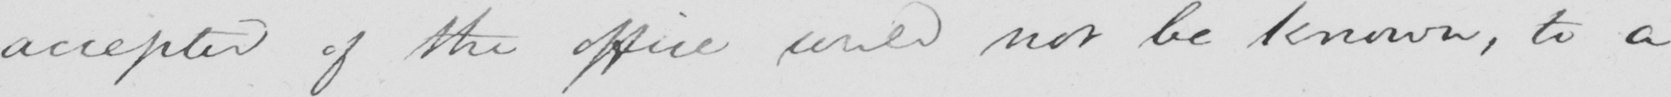Transcribe the text shown in this historical manuscript line. accepted of the office would not be known , to a 